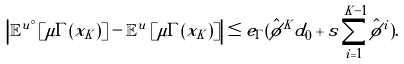Convert formula to latex. <formula><loc_0><loc_0><loc_500><loc_500>\left | \mathbb { E } ^ { u ^ { \circ } } \left [ \mu \Gamma ( x _ { K } ) \right ] - \mathbb { E } ^ { u } \left [ \mu \Gamma ( x _ { K } ) \right ] \right | \leq e _ { \Gamma } ( \hat { \phi } ^ { K } d _ { 0 } + s \sum _ { i = 1 } ^ { K - 1 } \hat { \phi } ^ { i } ) .</formula> 